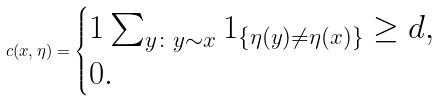Convert formula to latex. <formula><loc_0><loc_0><loc_500><loc_500>c ( x , \eta ) = \begin{cases} 1 \sum _ { y \colon y \sim x } 1 _ { \{ \eta ( y ) \neq \eta ( x ) \} } \geq d , \\ 0 . \end{cases}</formula> 